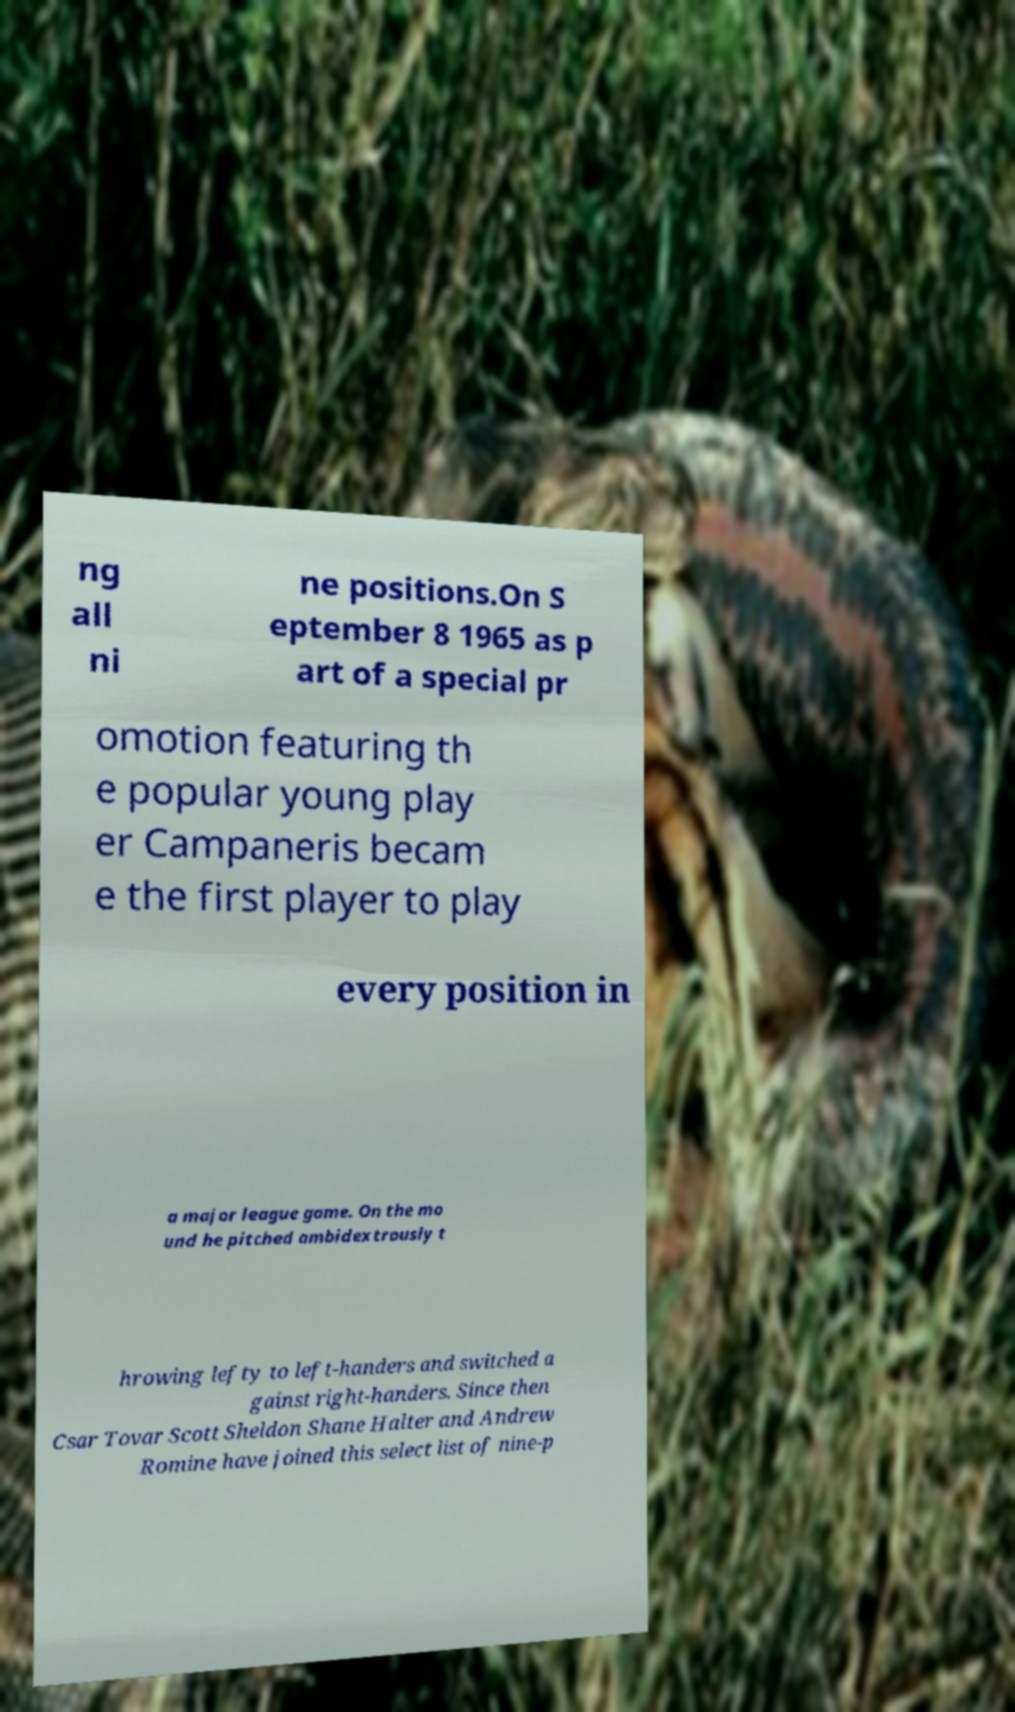Can you accurately transcribe the text from the provided image for me? ng all ni ne positions.On S eptember 8 1965 as p art of a special pr omotion featuring th e popular young play er Campaneris becam e the first player to play every position in a major league game. On the mo und he pitched ambidextrously t hrowing lefty to left-handers and switched a gainst right-handers. Since then Csar Tovar Scott Sheldon Shane Halter and Andrew Romine have joined this select list of nine-p 